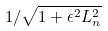Convert formula to latex. <formula><loc_0><loc_0><loc_500><loc_500>1 / \sqrt { 1 + \epsilon ^ { 2 } L _ { n } ^ { 2 } }</formula> 